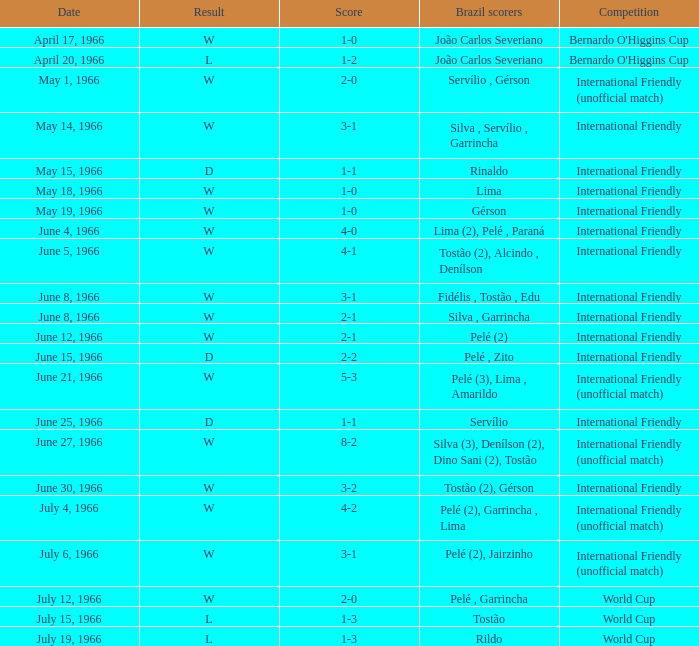What is the outcome of the international friendly competition on may 15, 1966? D. 